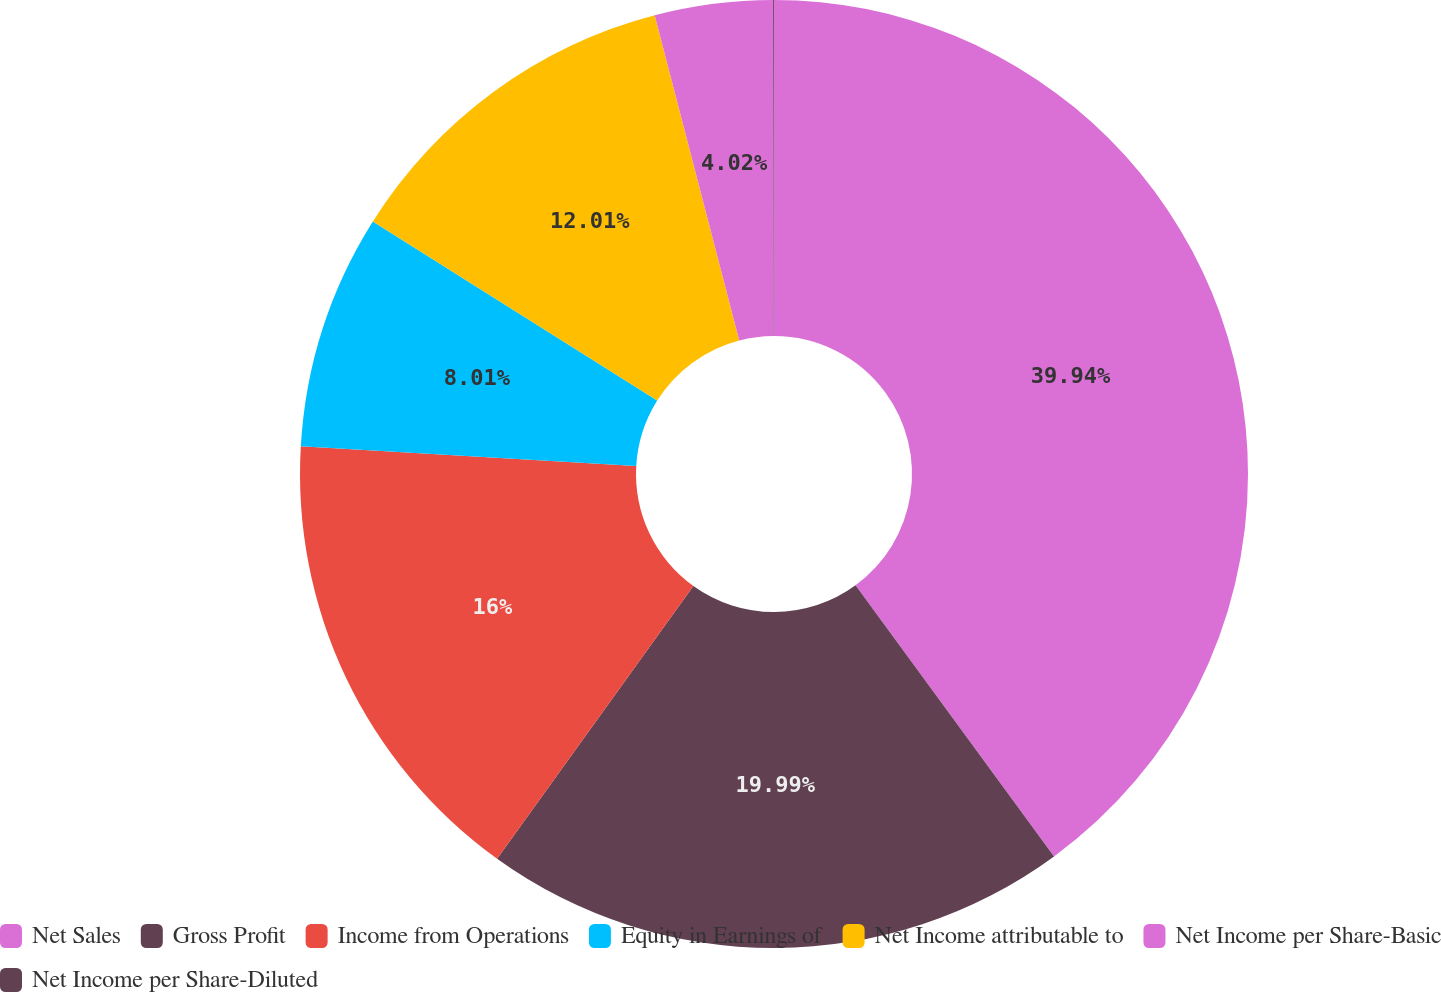Convert chart. <chart><loc_0><loc_0><loc_500><loc_500><pie_chart><fcel>Net Sales<fcel>Gross Profit<fcel>Income from Operations<fcel>Equity in Earnings of<fcel>Net Income attributable to<fcel>Net Income per Share-Basic<fcel>Net Income per Share-Diluted<nl><fcel>39.94%<fcel>19.99%<fcel>16.0%<fcel>8.01%<fcel>12.01%<fcel>4.02%<fcel>0.03%<nl></chart> 